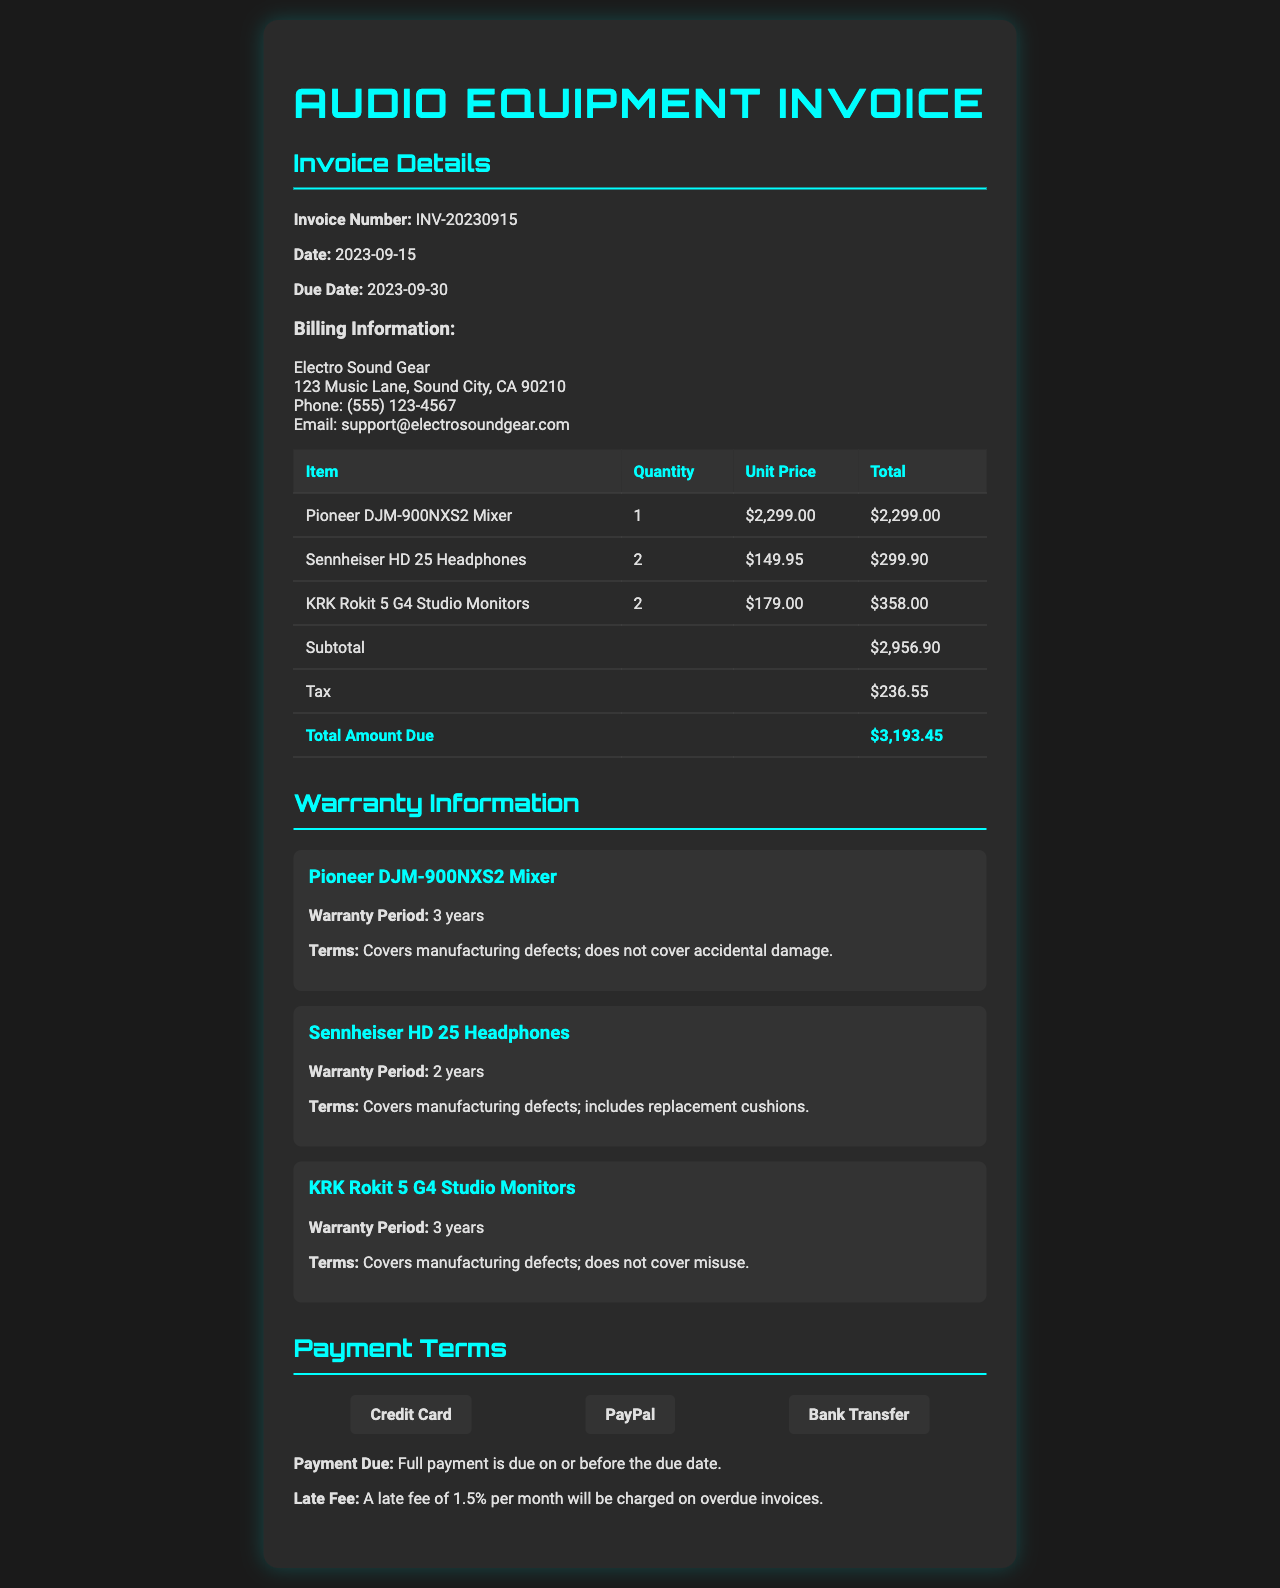What is the invoice number? The invoice number is clearly listed under the invoice details section.
Answer: INV-20230915 What is the total amount due? The total amount due is summarized in the table at the bottom of the invoice details.
Answer: $3,193.45 How long is the warranty period for the Sennheiser HD 25 Headphones? The warranty period is specified in the warranty information section for each item.
Answer: 2 years What is the due date for payment? The due date is mentioned in the invoice details section along with the invoice date.
Answer: 2023-09-30 What are the payment methods accepted? The payment methods are listed in the payment terms section, indicating various options.
Answer: Credit Card, PayPal, Bank Transfer What type of defects does the warranty for the KRK Rokit 5 G4 Studio Monitors cover? The warranty terms specify the type of defects covered as well as those not covered.
Answer: Manufacturing defects What is the late fee percentage for overdue invoices? The late fee is described in the payment terms, providing clarity on penalties for delayed payment.
Answer: 1.5% per month What items are listed under the invoice? The items are outlined in the table detailing the purchased equipment with quantities and prices.
Answer: Pioneer DJM-900NXS2 Mixer, Sennheiser HD 25 Headphones, KRK Rokit 5 G4 Studio Monitors 